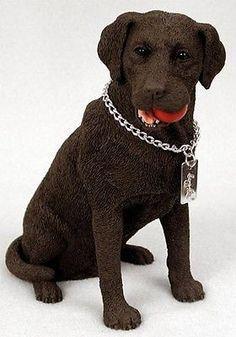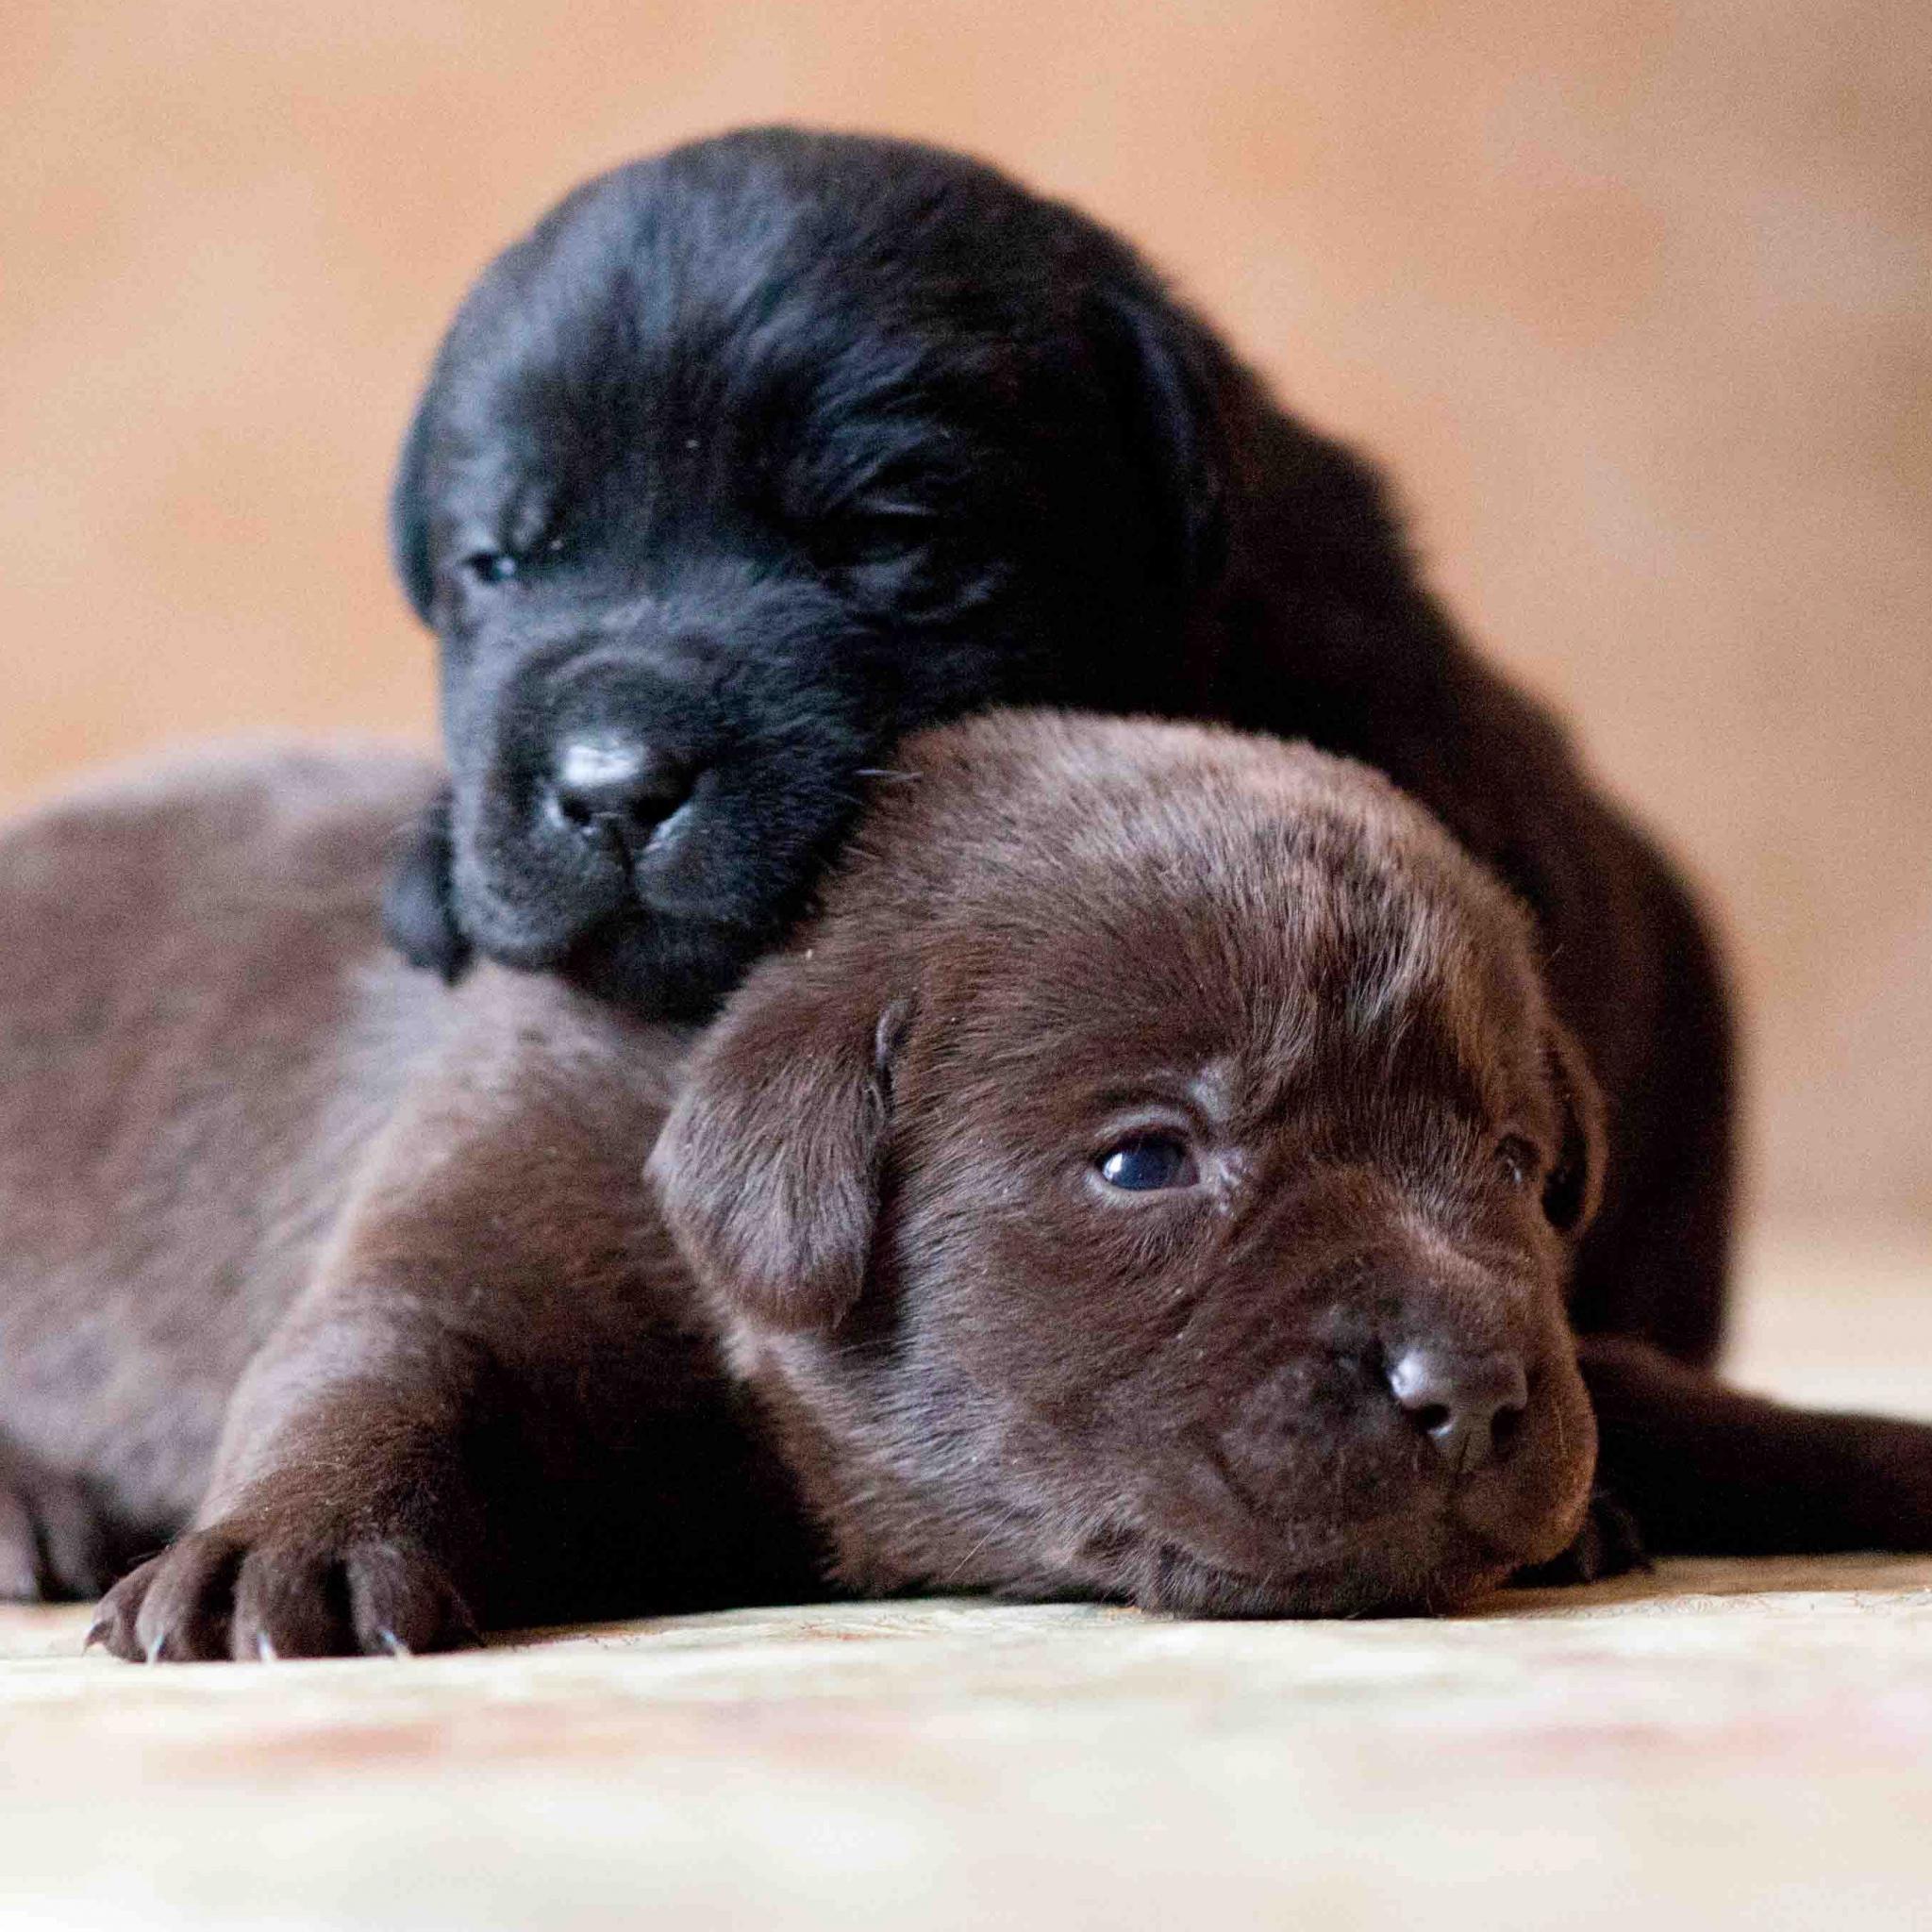The first image is the image on the left, the second image is the image on the right. Examine the images to the left and right. Is the description "There are exactly four dogs." accurate? Answer yes or no. No. The first image is the image on the left, the second image is the image on the right. For the images displayed, is the sentence "There are exactly four dogs in total." factually correct? Answer yes or no. No. 